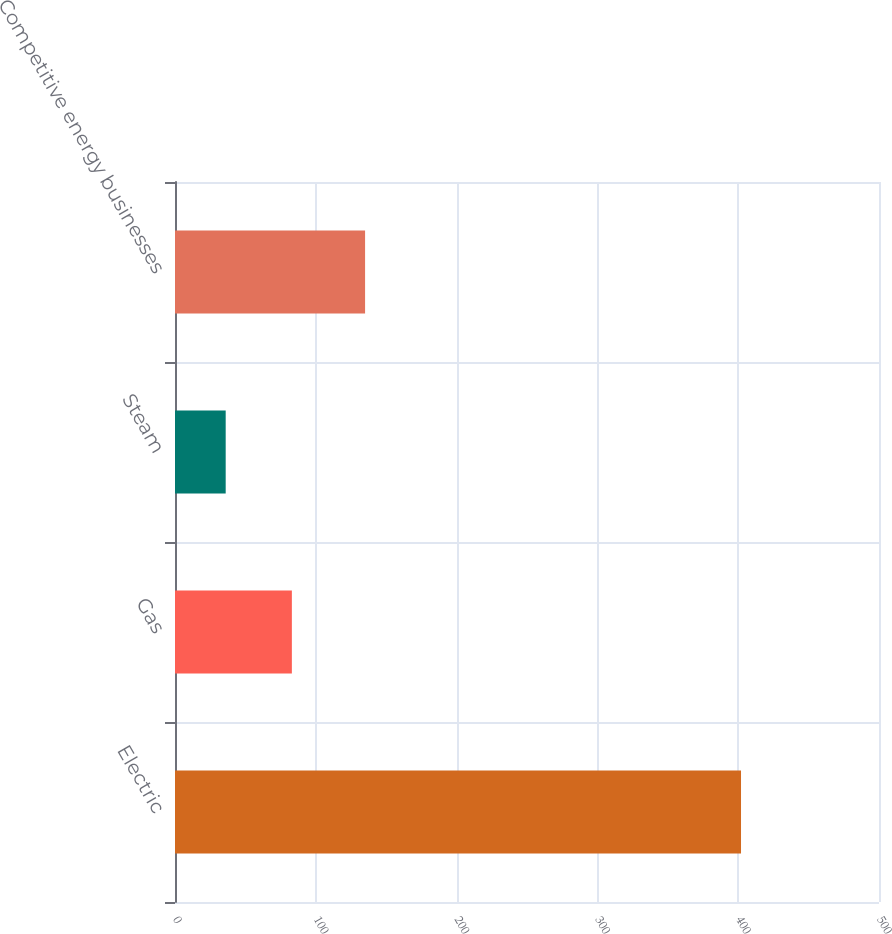Convert chart. <chart><loc_0><loc_0><loc_500><loc_500><bar_chart><fcel>Electric<fcel>Gas<fcel>Steam<fcel>Competitive energy businesses<nl><fcel>402<fcel>83<fcel>36<fcel>135<nl></chart> 